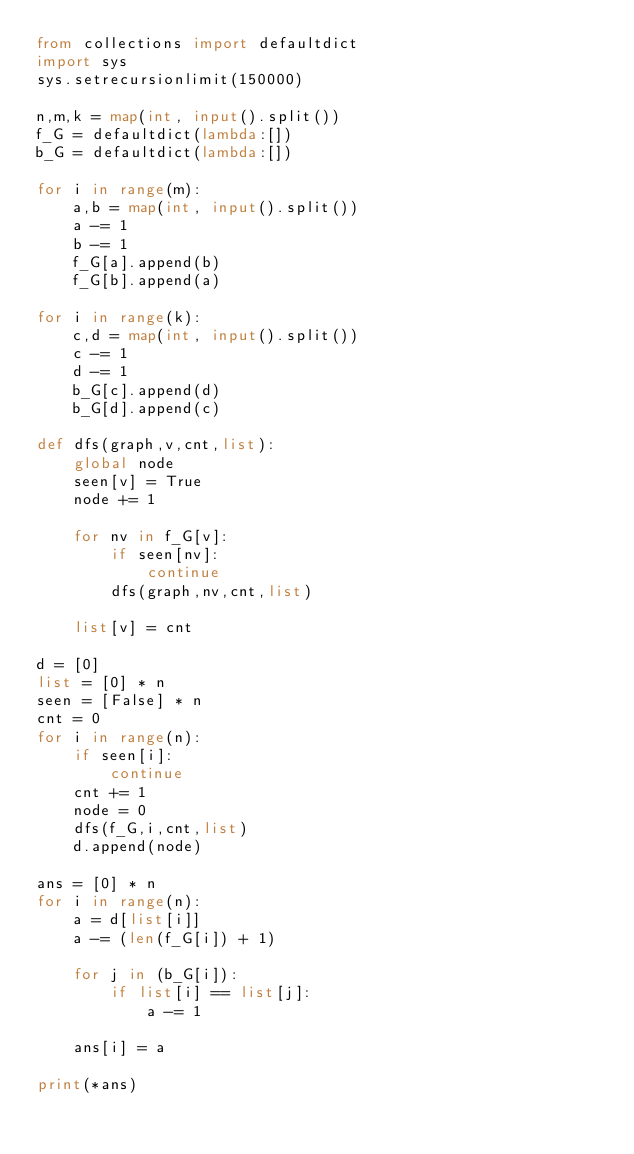Convert code to text. <code><loc_0><loc_0><loc_500><loc_500><_Python_>from collections import defaultdict
import sys
sys.setrecursionlimit(150000)

n,m,k = map(int, input().split())
f_G = defaultdict(lambda:[])
b_G = defaultdict(lambda:[])

for i in range(m):
    a,b = map(int, input().split())
    a -= 1
    b -= 1
    f_G[a].append(b)
    f_G[b].append(a)

for i in range(k):
    c,d = map(int, input().split())
    c -= 1
    d -= 1
    b_G[c].append(d)
    b_G[d].append(c)

def dfs(graph,v,cnt,list):
    global node
    seen[v] = True
    node += 1

    for nv in f_G[v]:
        if seen[nv]:
            continue
        dfs(graph,nv,cnt,list)

    list[v] = cnt

d = [0]
list = [0] * n
seen = [False] * n
cnt = 0
for i in range(n):
    if seen[i]:
        continue
    cnt += 1
    node = 0
    dfs(f_G,i,cnt,list)
    d.append(node)

ans = [0] * n
for i in range(n):
    a = d[list[i]]
    a -= (len(f_G[i]) + 1)

    for j in (b_G[i]):
        if list[i] == list[j]:
            a -= 1

    ans[i] = a

print(*ans)
</code> 